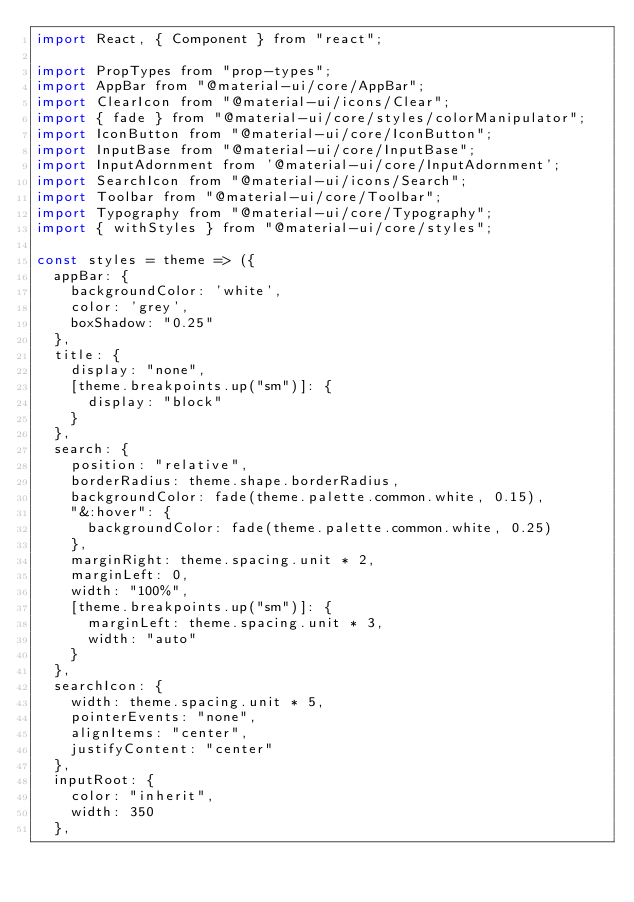<code> <loc_0><loc_0><loc_500><loc_500><_JavaScript_>import React, { Component } from "react";

import PropTypes from "prop-types";
import AppBar from "@material-ui/core/AppBar";
import ClearIcon from "@material-ui/icons/Clear";
import { fade } from "@material-ui/core/styles/colorManipulator";
import IconButton from "@material-ui/core/IconButton";
import InputBase from "@material-ui/core/InputBase";
import InputAdornment from '@material-ui/core/InputAdornment';
import SearchIcon from "@material-ui/icons/Search";
import Toolbar from "@material-ui/core/Toolbar";
import Typography from "@material-ui/core/Typography";
import { withStyles } from "@material-ui/core/styles";

const styles = theme => ({  
  appBar: {
    backgroundColor: 'white',
    color: 'grey',
    boxShadow: "0.25"
  },
  title: {
    display: "none",
    [theme.breakpoints.up("sm")]: {
      display: "block"
    }
  },
  search: {
    position: "relative",
    borderRadius: theme.shape.borderRadius,
    backgroundColor: fade(theme.palette.common.white, 0.15),
    "&:hover": {
      backgroundColor: fade(theme.palette.common.white, 0.25)
    },
    marginRight: theme.spacing.unit * 2,
    marginLeft: 0,
    width: "100%",
    [theme.breakpoints.up("sm")]: {
      marginLeft: theme.spacing.unit * 3,
      width: "auto"
    }
  },
  searchIcon: {
    width: theme.spacing.unit * 5,
    pointerEvents: "none",
    alignItems: "center",
    justifyContent: "center"
  },
  inputRoot: {
    color: "inherit",
    width: 350
  },</code> 